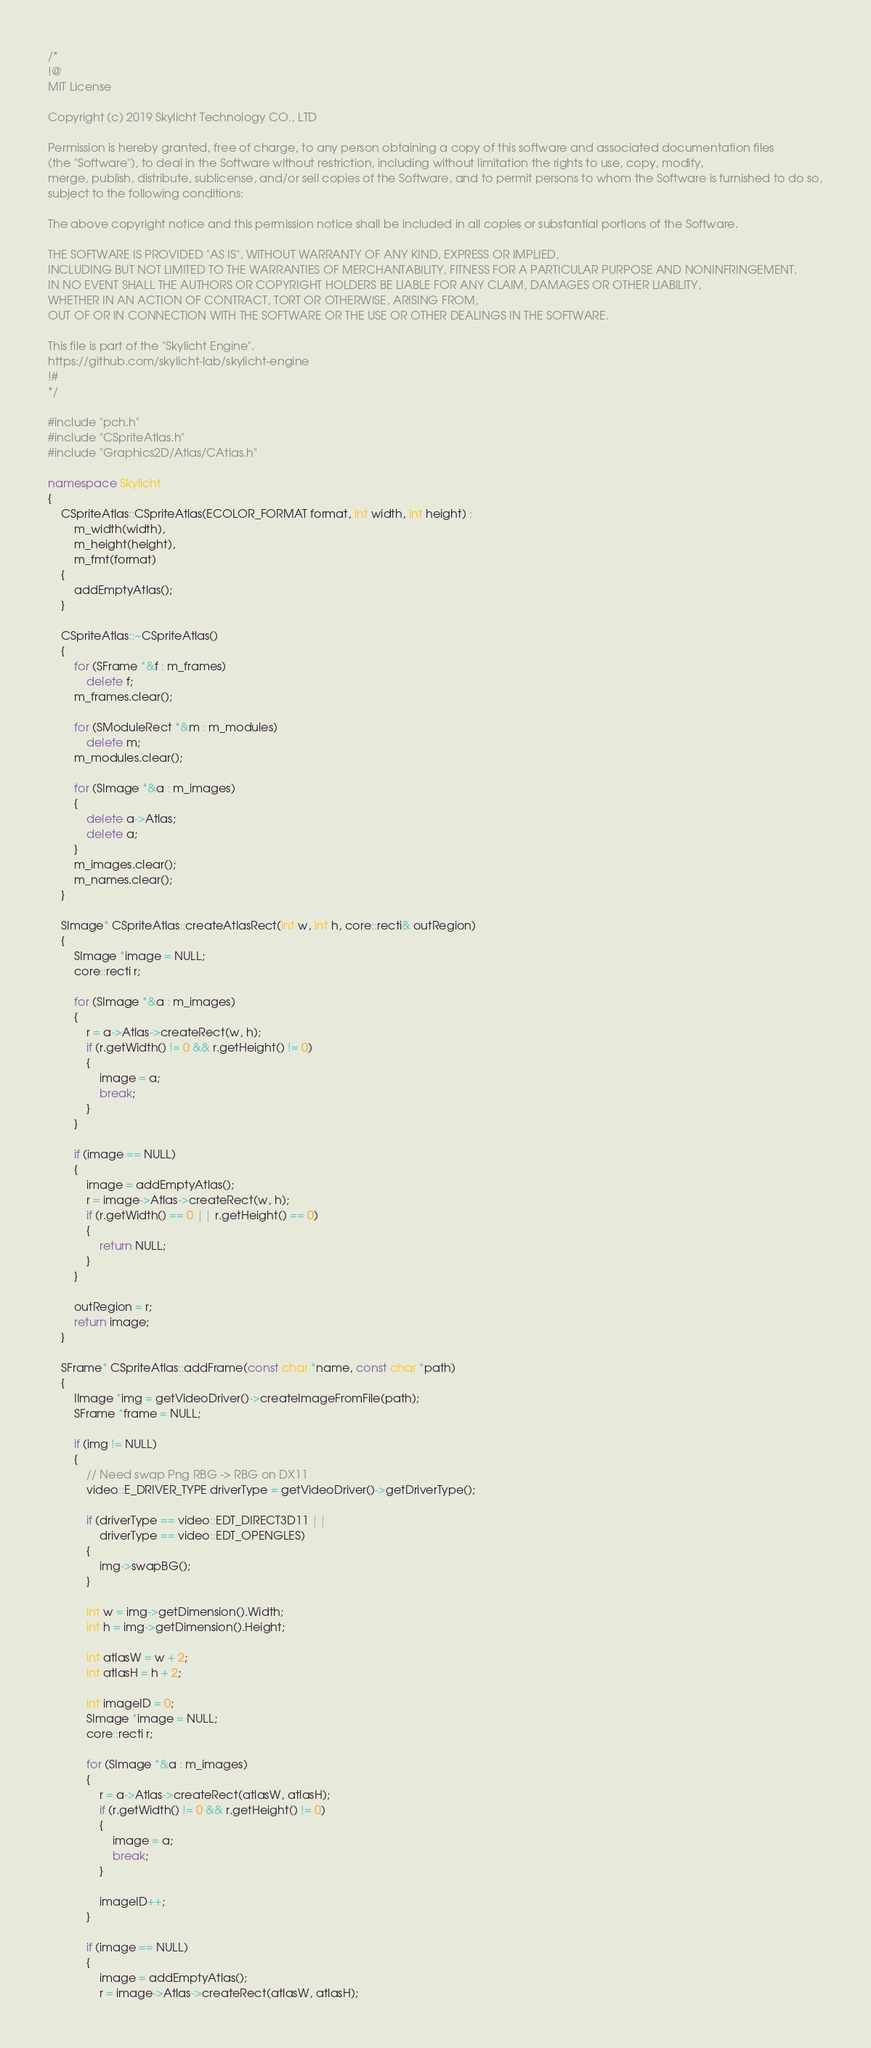<code> <loc_0><loc_0><loc_500><loc_500><_C++_>/*
!@
MIT License

Copyright (c) 2019 Skylicht Technology CO., LTD

Permission is hereby granted, free of charge, to any person obtaining a copy of this software and associated documentation files
(the "Software"), to deal in the Software without restriction, including without limitation the rights to use, copy, modify,
merge, publish, distribute, sublicense, and/or sell copies of the Software, and to permit persons to whom the Software is furnished to do so,
subject to the following conditions:

The above copyright notice and this permission notice shall be included in all copies or substantial portions of the Software.

THE SOFTWARE IS PROVIDED "AS IS", WITHOUT WARRANTY OF ANY KIND, EXPRESS OR IMPLIED,
INCLUDING BUT NOT LIMITED TO THE WARRANTIES OF MERCHANTABILITY, FITNESS FOR A PARTICULAR PURPOSE AND NONINFRINGEMENT.
IN NO EVENT SHALL THE AUTHORS OR COPYRIGHT HOLDERS BE LIABLE FOR ANY CLAIM, DAMAGES OR OTHER LIABILITY,
WHETHER IN AN ACTION OF CONTRACT, TORT OR OTHERWISE, ARISING FROM,
OUT OF OR IN CONNECTION WITH THE SOFTWARE OR THE USE OR OTHER DEALINGS IN THE SOFTWARE.

This file is part of the "Skylicht Engine".
https://github.com/skylicht-lab/skylicht-engine
!#
*/

#include "pch.h"
#include "CSpriteAtlas.h"
#include "Graphics2D/Atlas/CAtlas.h"

namespace Skylicht
{
	CSpriteAtlas::CSpriteAtlas(ECOLOR_FORMAT format, int width, int height) :
		m_width(width),
		m_height(height),
		m_fmt(format)
	{
		addEmptyAtlas();
	}

	CSpriteAtlas::~CSpriteAtlas()
	{
		for (SFrame *&f : m_frames)
			delete f;
		m_frames.clear();

		for (SModuleRect *&m : m_modules)
			delete m;
		m_modules.clear();

		for (SImage *&a : m_images)
		{
			delete a->Atlas;
			delete a;
		}
		m_images.clear();
		m_names.clear();
	}

	SImage* CSpriteAtlas::createAtlasRect(int w, int h, core::recti& outRegion)
	{
		SImage *image = NULL;
		core::recti r;

		for (SImage *&a : m_images)
		{
			r = a->Atlas->createRect(w, h);
			if (r.getWidth() != 0 && r.getHeight() != 0)
			{
				image = a;
				break;
			}
		}

		if (image == NULL)
		{
			image = addEmptyAtlas();
			r = image->Atlas->createRect(w, h);
			if (r.getWidth() == 0 || r.getHeight() == 0)
			{
				return NULL;
			}
		}

		outRegion = r;
		return image;
	}

	SFrame* CSpriteAtlas::addFrame(const char *name, const char *path)
	{
		IImage *img = getVideoDriver()->createImageFromFile(path);
		SFrame *frame = NULL;

		if (img != NULL)
		{
			// Need swap Png RBG -> RBG on DX11
			video::E_DRIVER_TYPE driverType = getVideoDriver()->getDriverType();

			if (driverType == video::EDT_DIRECT3D11 ||
				driverType == video::EDT_OPENGLES)
			{
				img->swapBG();
			}

			int w = img->getDimension().Width;
			int h = img->getDimension().Height;

			int atlasW = w + 2;
			int atlasH = h + 2;

			int imageID = 0;
			SImage *image = NULL;
			core::recti r;

			for (SImage *&a : m_images)
			{
				r = a->Atlas->createRect(atlasW, atlasH);
				if (r.getWidth() != 0 && r.getHeight() != 0)
				{
					image = a;
					break;
				}

				imageID++;
			}

			if (image == NULL)
			{
				image = addEmptyAtlas();
				r = image->Atlas->createRect(atlasW, atlasH);</code> 